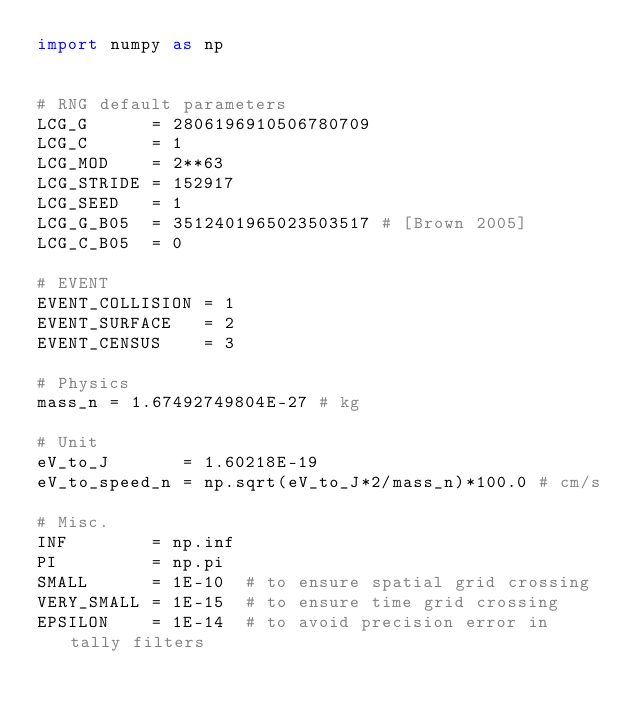<code> <loc_0><loc_0><loc_500><loc_500><_Python_>import numpy as np


# RNG default parameters
LCG_G      = 2806196910506780709
LCG_C      = 1
LCG_MOD    = 2**63
LCG_STRIDE = 152917
LCG_SEED   = 1
LCG_G_B05  = 3512401965023503517 # [Brown 2005]
LCG_C_B05  = 0

# EVENT
EVENT_COLLISION = 1
EVENT_SURFACE   = 2
EVENT_CENSUS    = 3

# Physics
mass_n = 1.67492749804E-27 # kg

# Unit
eV_to_J       = 1.60218E-19
eV_to_speed_n = np.sqrt(eV_to_J*2/mass_n)*100.0 # cm/s

# Misc.
INF        = np.inf
PI         = np.pi
SMALL      = 1E-10  # to ensure spatial grid crossing
VERY_SMALL = 1E-15  # to ensure time grid crossing
EPSILON    = 1E-14  # to avoid precision error in tally filters
</code> 